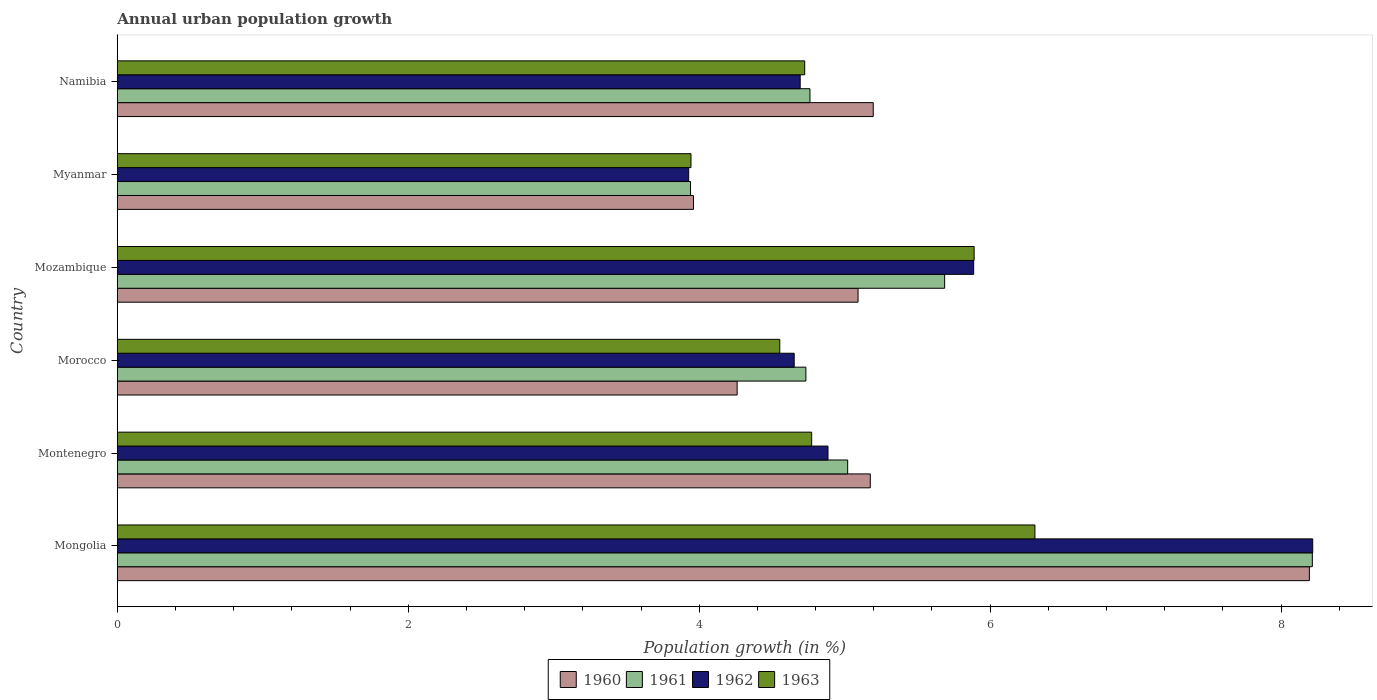How many different coloured bars are there?
Your response must be concise. 4. How many groups of bars are there?
Keep it short and to the point. 6. Are the number of bars on each tick of the Y-axis equal?
Your response must be concise. Yes. How many bars are there on the 4th tick from the bottom?
Your response must be concise. 4. What is the label of the 2nd group of bars from the top?
Provide a succinct answer. Myanmar. What is the percentage of urban population growth in 1963 in Mongolia?
Your answer should be compact. 6.31. Across all countries, what is the maximum percentage of urban population growth in 1960?
Ensure brevity in your answer.  8.19. Across all countries, what is the minimum percentage of urban population growth in 1962?
Make the answer very short. 3.93. In which country was the percentage of urban population growth in 1961 maximum?
Ensure brevity in your answer.  Mongolia. In which country was the percentage of urban population growth in 1962 minimum?
Make the answer very short. Myanmar. What is the total percentage of urban population growth in 1960 in the graph?
Provide a short and direct response. 31.88. What is the difference between the percentage of urban population growth in 1963 in Morocco and that in Namibia?
Give a very brief answer. -0.17. What is the difference between the percentage of urban population growth in 1962 in Morocco and the percentage of urban population growth in 1961 in Myanmar?
Your answer should be very brief. 0.71. What is the average percentage of urban population growth in 1962 per country?
Provide a succinct answer. 5.38. What is the difference between the percentage of urban population growth in 1961 and percentage of urban population growth in 1962 in Morocco?
Your response must be concise. 0.08. What is the ratio of the percentage of urban population growth in 1961 in Morocco to that in Namibia?
Your answer should be very brief. 0.99. Is the percentage of urban population growth in 1963 in Mongolia less than that in Myanmar?
Provide a short and direct response. No. Is the difference between the percentage of urban population growth in 1961 in Montenegro and Namibia greater than the difference between the percentage of urban population growth in 1962 in Montenegro and Namibia?
Ensure brevity in your answer.  Yes. What is the difference between the highest and the second highest percentage of urban population growth in 1960?
Your answer should be compact. 3. What is the difference between the highest and the lowest percentage of urban population growth in 1963?
Provide a succinct answer. 2.36. In how many countries, is the percentage of urban population growth in 1963 greater than the average percentage of urban population growth in 1963 taken over all countries?
Keep it short and to the point. 2. What does the 4th bar from the top in Mongolia represents?
Offer a terse response. 1960. What does the 2nd bar from the bottom in Mozambique represents?
Your response must be concise. 1961. How many bars are there?
Offer a terse response. 24. Are all the bars in the graph horizontal?
Offer a very short reply. Yes. What is the difference between two consecutive major ticks on the X-axis?
Provide a succinct answer. 2. Does the graph contain grids?
Make the answer very short. No. Where does the legend appear in the graph?
Keep it short and to the point. Bottom center. How many legend labels are there?
Provide a succinct answer. 4. How are the legend labels stacked?
Ensure brevity in your answer.  Horizontal. What is the title of the graph?
Your answer should be very brief. Annual urban population growth. Does "1992" appear as one of the legend labels in the graph?
Your answer should be very brief. No. What is the label or title of the X-axis?
Keep it short and to the point. Population growth (in %). What is the label or title of the Y-axis?
Provide a short and direct response. Country. What is the Population growth (in %) in 1960 in Mongolia?
Keep it short and to the point. 8.19. What is the Population growth (in %) in 1961 in Mongolia?
Ensure brevity in your answer.  8.21. What is the Population growth (in %) in 1962 in Mongolia?
Offer a terse response. 8.22. What is the Population growth (in %) in 1963 in Mongolia?
Offer a terse response. 6.31. What is the Population growth (in %) in 1960 in Montenegro?
Offer a very short reply. 5.18. What is the Population growth (in %) in 1961 in Montenegro?
Give a very brief answer. 5.02. What is the Population growth (in %) of 1962 in Montenegro?
Your response must be concise. 4.89. What is the Population growth (in %) in 1963 in Montenegro?
Ensure brevity in your answer.  4.77. What is the Population growth (in %) of 1960 in Morocco?
Your answer should be compact. 4.26. What is the Population growth (in %) in 1961 in Morocco?
Offer a terse response. 4.73. What is the Population growth (in %) in 1962 in Morocco?
Your response must be concise. 4.65. What is the Population growth (in %) in 1963 in Morocco?
Keep it short and to the point. 4.55. What is the Population growth (in %) in 1960 in Mozambique?
Your response must be concise. 5.09. What is the Population growth (in %) in 1961 in Mozambique?
Your response must be concise. 5.69. What is the Population growth (in %) in 1962 in Mozambique?
Your answer should be very brief. 5.89. What is the Population growth (in %) in 1963 in Mozambique?
Offer a very short reply. 5.89. What is the Population growth (in %) in 1960 in Myanmar?
Offer a very short reply. 3.96. What is the Population growth (in %) of 1961 in Myanmar?
Keep it short and to the point. 3.94. What is the Population growth (in %) of 1962 in Myanmar?
Offer a terse response. 3.93. What is the Population growth (in %) of 1963 in Myanmar?
Make the answer very short. 3.94. What is the Population growth (in %) of 1960 in Namibia?
Ensure brevity in your answer.  5.2. What is the Population growth (in %) of 1961 in Namibia?
Keep it short and to the point. 4.76. What is the Population growth (in %) in 1962 in Namibia?
Provide a short and direct response. 4.69. What is the Population growth (in %) in 1963 in Namibia?
Ensure brevity in your answer.  4.73. Across all countries, what is the maximum Population growth (in %) in 1960?
Your answer should be very brief. 8.19. Across all countries, what is the maximum Population growth (in %) in 1961?
Make the answer very short. 8.21. Across all countries, what is the maximum Population growth (in %) of 1962?
Provide a short and direct response. 8.22. Across all countries, what is the maximum Population growth (in %) of 1963?
Offer a very short reply. 6.31. Across all countries, what is the minimum Population growth (in %) of 1960?
Your response must be concise. 3.96. Across all countries, what is the minimum Population growth (in %) of 1961?
Your response must be concise. 3.94. Across all countries, what is the minimum Population growth (in %) in 1962?
Offer a terse response. 3.93. Across all countries, what is the minimum Population growth (in %) in 1963?
Your answer should be very brief. 3.94. What is the total Population growth (in %) in 1960 in the graph?
Your answer should be compact. 31.88. What is the total Population growth (in %) of 1961 in the graph?
Provide a short and direct response. 32.36. What is the total Population growth (in %) in 1962 in the graph?
Provide a short and direct response. 32.26. What is the total Population growth (in %) in 1963 in the graph?
Give a very brief answer. 30.19. What is the difference between the Population growth (in %) in 1960 in Mongolia and that in Montenegro?
Your answer should be compact. 3.02. What is the difference between the Population growth (in %) of 1961 in Mongolia and that in Montenegro?
Ensure brevity in your answer.  3.19. What is the difference between the Population growth (in %) of 1962 in Mongolia and that in Montenegro?
Keep it short and to the point. 3.33. What is the difference between the Population growth (in %) in 1963 in Mongolia and that in Montenegro?
Ensure brevity in your answer.  1.53. What is the difference between the Population growth (in %) in 1960 in Mongolia and that in Morocco?
Provide a succinct answer. 3.93. What is the difference between the Population growth (in %) in 1961 in Mongolia and that in Morocco?
Your response must be concise. 3.48. What is the difference between the Population growth (in %) in 1962 in Mongolia and that in Morocco?
Your answer should be very brief. 3.56. What is the difference between the Population growth (in %) of 1963 in Mongolia and that in Morocco?
Make the answer very short. 1.75. What is the difference between the Population growth (in %) in 1960 in Mongolia and that in Mozambique?
Your answer should be very brief. 3.1. What is the difference between the Population growth (in %) of 1961 in Mongolia and that in Mozambique?
Offer a terse response. 2.53. What is the difference between the Population growth (in %) of 1962 in Mongolia and that in Mozambique?
Ensure brevity in your answer.  2.33. What is the difference between the Population growth (in %) in 1963 in Mongolia and that in Mozambique?
Keep it short and to the point. 0.42. What is the difference between the Population growth (in %) of 1960 in Mongolia and that in Myanmar?
Your answer should be very brief. 4.23. What is the difference between the Population growth (in %) of 1961 in Mongolia and that in Myanmar?
Your answer should be very brief. 4.27. What is the difference between the Population growth (in %) in 1962 in Mongolia and that in Myanmar?
Give a very brief answer. 4.29. What is the difference between the Population growth (in %) in 1963 in Mongolia and that in Myanmar?
Provide a short and direct response. 2.36. What is the difference between the Population growth (in %) of 1960 in Mongolia and that in Namibia?
Give a very brief answer. 3. What is the difference between the Population growth (in %) in 1961 in Mongolia and that in Namibia?
Your answer should be compact. 3.45. What is the difference between the Population growth (in %) of 1962 in Mongolia and that in Namibia?
Make the answer very short. 3.52. What is the difference between the Population growth (in %) of 1963 in Mongolia and that in Namibia?
Offer a terse response. 1.58. What is the difference between the Population growth (in %) in 1960 in Montenegro and that in Morocco?
Your answer should be compact. 0.92. What is the difference between the Population growth (in %) of 1961 in Montenegro and that in Morocco?
Provide a succinct answer. 0.29. What is the difference between the Population growth (in %) of 1962 in Montenegro and that in Morocco?
Your answer should be very brief. 0.23. What is the difference between the Population growth (in %) in 1963 in Montenegro and that in Morocco?
Ensure brevity in your answer.  0.22. What is the difference between the Population growth (in %) in 1960 in Montenegro and that in Mozambique?
Provide a succinct answer. 0.08. What is the difference between the Population growth (in %) in 1962 in Montenegro and that in Mozambique?
Give a very brief answer. -1. What is the difference between the Population growth (in %) in 1963 in Montenegro and that in Mozambique?
Make the answer very short. -1.12. What is the difference between the Population growth (in %) in 1960 in Montenegro and that in Myanmar?
Your response must be concise. 1.22. What is the difference between the Population growth (in %) of 1962 in Montenegro and that in Myanmar?
Offer a very short reply. 0.96. What is the difference between the Population growth (in %) in 1963 in Montenegro and that in Myanmar?
Make the answer very short. 0.83. What is the difference between the Population growth (in %) of 1960 in Montenegro and that in Namibia?
Your response must be concise. -0.02. What is the difference between the Population growth (in %) in 1961 in Montenegro and that in Namibia?
Your answer should be compact. 0.26. What is the difference between the Population growth (in %) of 1962 in Montenegro and that in Namibia?
Make the answer very short. 0.19. What is the difference between the Population growth (in %) of 1963 in Montenegro and that in Namibia?
Offer a terse response. 0.05. What is the difference between the Population growth (in %) of 1960 in Morocco and that in Mozambique?
Keep it short and to the point. -0.83. What is the difference between the Population growth (in %) in 1961 in Morocco and that in Mozambique?
Your answer should be very brief. -0.95. What is the difference between the Population growth (in %) of 1962 in Morocco and that in Mozambique?
Give a very brief answer. -1.23. What is the difference between the Population growth (in %) of 1963 in Morocco and that in Mozambique?
Ensure brevity in your answer.  -1.34. What is the difference between the Population growth (in %) in 1960 in Morocco and that in Myanmar?
Offer a very short reply. 0.3. What is the difference between the Population growth (in %) of 1961 in Morocco and that in Myanmar?
Provide a short and direct response. 0.79. What is the difference between the Population growth (in %) of 1962 in Morocco and that in Myanmar?
Offer a very short reply. 0.73. What is the difference between the Population growth (in %) of 1963 in Morocco and that in Myanmar?
Your answer should be very brief. 0.61. What is the difference between the Population growth (in %) of 1960 in Morocco and that in Namibia?
Make the answer very short. -0.94. What is the difference between the Population growth (in %) in 1961 in Morocco and that in Namibia?
Provide a short and direct response. -0.03. What is the difference between the Population growth (in %) of 1962 in Morocco and that in Namibia?
Provide a short and direct response. -0.04. What is the difference between the Population growth (in %) in 1963 in Morocco and that in Namibia?
Ensure brevity in your answer.  -0.17. What is the difference between the Population growth (in %) in 1960 in Mozambique and that in Myanmar?
Provide a short and direct response. 1.13. What is the difference between the Population growth (in %) of 1961 in Mozambique and that in Myanmar?
Give a very brief answer. 1.75. What is the difference between the Population growth (in %) in 1962 in Mozambique and that in Myanmar?
Offer a terse response. 1.96. What is the difference between the Population growth (in %) in 1963 in Mozambique and that in Myanmar?
Offer a very short reply. 1.95. What is the difference between the Population growth (in %) in 1960 in Mozambique and that in Namibia?
Your answer should be very brief. -0.1. What is the difference between the Population growth (in %) of 1961 in Mozambique and that in Namibia?
Make the answer very short. 0.93. What is the difference between the Population growth (in %) of 1962 in Mozambique and that in Namibia?
Give a very brief answer. 1.19. What is the difference between the Population growth (in %) of 1963 in Mozambique and that in Namibia?
Give a very brief answer. 1.16. What is the difference between the Population growth (in %) in 1960 in Myanmar and that in Namibia?
Make the answer very short. -1.24. What is the difference between the Population growth (in %) in 1961 in Myanmar and that in Namibia?
Provide a short and direct response. -0.82. What is the difference between the Population growth (in %) in 1962 in Myanmar and that in Namibia?
Your response must be concise. -0.77. What is the difference between the Population growth (in %) of 1963 in Myanmar and that in Namibia?
Ensure brevity in your answer.  -0.78. What is the difference between the Population growth (in %) of 1960 in Mongolia and the Population growth (in %) of 1961 in Montenegro?
Keep it short and to the point. 3.17. What is the difference between the Population growth (in %) of 1960 in Mongolia and the Population growth (in %) of 1962 in Montenegro?
Give a very brief answer. 3.31. What is the difference between the Population growth (in %) of 1960 in Mongolia and the Population growth (in %) of 1963 in Montenegro?
Your answer should be very brief. 3.42. What is the difference between the Population growth (in %) in 1961 in Mongolia and the Population growth (in %) in 1962 in Montenegro?
Your response must be concise. 3.33. What is the difference between the Population growth (in %) of 1961 in Mongolia and the Population growth (in %) of 1963 in Montenegro?
Provide a short and direct response. 3.44. What is the difference between the Population growth (in %) in 1962 in Mongolia and the Population growth (in %) in 1963 in Montenegro?
Provide a short and direct response. 3.44. What is the difference between the Population growth (in %) in 1960 in Mongolia and the Population growth (in %) in 1961 in Morocco?
Ensure brevity in your answer.  3.46. What is the difference between the Population growth (in %) of 1960 in Mongolia and the Population growth (in %) of 1962 in Morocco?
Offer a very short reply. 3.54. What is the difference between the Population growth (in %) in 1960 in Mongolia and the Population growth (in %) in 1963 in Morocco?
Make the answer very short. 3.64. What is the difference between the Population growth (in %) in 1961 in Mongolia and the Population growth (in %) in 1962 in Morocco?
Provide a succinct answer. 3.56. What is the difference between the Population growth (in %) in 1961 in Mongolia and the Population growth (in %) in 1963 in Morocco?
Keep it short and to the point. 3.66. What is the difference between the Population growth (in %) in 1962 in Mongolia and the Population growth (in %) in 1963 in Morocco?
Make the answer very short. 3.66. What is the difference between the Population growth (in %) of 1960 in Mongolia and the Population growth (in %) of 1961 in Mozambique?
Ensure brevity in your answer.  2.51. What is the difference between the Population growth (in %) in 1960 in Mongolia and the Population growth (in %) in 1962 in Mozambique?
Give a very brief answer. 2.31. What is the difference between the Population growth (in %) in 1960 in Mongolia and the Population growth (in %) in 1963 in Mozambique?
Offer a terse response. 2.3. What is the difference between the Population growth (in %) in 1961 in Mongolia and the Population growth (in %) in 1962 in Mozambique?
Your answer should be very brief. 2.33. What is the difference between the Population growth (in %) in 1961 in Mongolia and the Population growth (in %) in 1963 in Mozambique?
Offer a terse response. 2.32. What is the difference between the Population growth (in %) of 1962 in Mongolia and the Population growth (in %) of 1963 in Mozambique?
Provide a succinct answer. 2.33. What is the difference between the Population growth (in %) in 1960 in Mongolia and the Population growth (in %) in 1961 in Myanmar?
Provide a short and direct response. 4.25. What is the difference between the Population growth (in %) in 1960 in Mongolia and the Population growth (in %) in 1962 in Myanmar?
Your response must be concise. 4.27. What is the difference between the Population growth (in %) of 1960 in Mongolia and the Population growth (in %) of 1963 in Myanmar?
Your response must be concise. 4.25. What is the difference between the Population growth (in %) of 1961 in Mongolia and the Population growth (in %) of 1962 in Myanmar?
Give a very brief answer. 4.29. What is the difference between the Population growth (in %) of 1961 in Mongolia and the Population growth (in %) of 1963 in Myanmar?
Your answer should be compact. 4.27. What is the difference between the Population growth (in %) in 1962 in Mongolia and the Population growth (in %) in 1963 in Myanmar?
Provide a succinct answer. 4.27. What is the difference between the Population growth (in %) in 1960 in Mongolia and the Population growth (in %) in 1961 in Namibia?
Make the answer very short. 3.43. What is the difference between the Population growth (in %) of 1960 in Mongolia and the Population growth (in %) of 1963 in Namibia?
Provide a short and direct response. 3.47. What is the difference between the Population growth (in %) of 1961 in Mongolia and the Population growth (in %) of 1962 in Namibia?
Keep it short and to the point. 3.52. What is the difference between the Population growth (in %) of 1961 in Mongolia and the Population growth (in %) of 1963 in Namibia?
Provide a succinct answer. 3.49. What is the difference between the Population growth (in %) in 1962 in Mongolia and the Population growth (in %) in 1963 in Namibia?
Your answer should be compact. 3.49. What is the difference between the Population growth (in %) of 1960 in Montenegro and the Population growth (in %) of 1961 in Morocco?
Provide a short and direct response. 0.44. What is the difference between the Population growth (in %) in 1960 in Montenegro and the Population growth (in %) in 1962 in Morocco?
Provide a succinct answer. 0.52. What is the difference between the Population growth (in %) of 1960 in Montenegro and the Population growth (in %) of 1963 in Morocco?
Provide a short and direct response. 0.62. What is the difference between the Population growth (in %) of 1961 in Montenegro and the Population growth (in %) of 1962 in Morocco?
Keep it short and to the point. 0.37. What is the difference between the Population growth (in %) of 1961 in Montenegro and the Population growth (in %) of 1963 in Morocco?
Provide a short and direct response. 0.47. What is the difference between the Population growth (in %) of 1962 in Montenegro and the Population growth (in %) of 1963 in Morocco?
Your answer should be compact. 0.33. What is the difference between the Population growth (in %) in 1960 in Montenegro and the Population growth (in %) in 1961 in Mozambique?
Offer a very short reply. -0.51. What is the difference between the Population growth (in %) of 1960 in Montenegro and the Population growth (in %) of 1962 in Mozambique?
Make the answer very short. -0.71. What is the difference between the Population growth (in %) of 1960 in Montenegro and the Population growth (in %) of 1963 in Mozambique?
Keep it short and to the point. -0.71. What is the difference between the Population growth (in %) in 1961 in Montenegro and the Population growth (in %) in 1962 in Mozambique?
Give a very brief answer. -0.87. What is the difference between the Population growth (in %) in 1961 in Montenegro and the Population growth (in %) in 1963 in Mozambique?
Ensure brevity in your answer.  -0.87. What is the difference between the Population growth (in %) of 1962 in Montenegro and the Population growth (in %) of 1963 in Mozambique?
Your answer should be very brief. -1. What is the difference between the Population growth (in %) in 1960 in Montenegro and the Population growth (in %) in 1961 in Myanmar?
Your answer should be very brief. 1.24. What is the difference between the Population growth (in %) in 1960 in Montenegro and the Population growth (in %) in 1962 in Myanmar?
Provide a short and direct response. 1.25. What is the difference between the Population growth (in %) of 1960 in Montenegro and the Population growth (in %) of 1963 in Myanmar?
Your response must be concise. 1.23. What is the difference between the Population growth (in %) of 1961 in Montenegro and the Population growth (in %) of 1962 in Myanmar?
Ensure brevity in your answer.  1.09. What is the difference between the Population growth (in %) in 1961 in Montenegro and the Population growth (in %) in 1963 in Myanmar?
Provide a short and direct response. 1.08. What is the difference between the Population growth (in %) of 1962 in Montenegro and the Population growth (in %) of 1963 in Myanmar?
Give a very brief answer. 0.94. What is the difference between the Population growth (in %) in 1960 in Montenegro and the Population growth (in %) in 1961 in Namibia?
Give a very brief answer. 0.41. What is the difference between the Population growth (in %) in 1960 in Montenegro and the Population growth (in %) in 1962 in Namibia?
Offer a terse response. 0.48. What is the difference between the Population growth (in %) of 1960 in Montenegro and the Population growth (in %) of 1963 in Namibia?
Your response must be concise. 0.45. What is the difference between the Population growth (in %) of 1961 in Montenegro and the Population growth (in %) of 1962 in Namibia?
Provide a succinct answer. 0.33. What is the difference between the Population growth (in %) in 1961 in Montenegro and the Population growth (in %) in 1963 in Namibia?
Your answer should be very brief. 0.3. What is the difference between the Population growth (in %) in 1962 in Montenegro and the Population growth (in %) in 1963 in Namibia?
Offer a terse response. 0.16. What is the difference between the Population growth (in %) in 1960 in Morocco and the Population growth (in %) in 1961 in Mozambique?
Your answer should be compact. -1.43. What is the difference between the Population growth (in %) of 1960 in Morocco and the Population growth (in %) of 1962 in Mozambique?
Your response must be concise. -1.63. What is the difference between the Population growth (in %) of 1960 in Morocco and the Population growth (in %) of 1963 in Mozambique?
Offer a very short reply. -1.63. What is the difference between the Population growth (in %) of 1961 in Morocco and the Population growth (in %) of 1962 in Mozambique?
Keep it short and to the point. -1.15. What is the difference between the Population growth (in %) in 1961 in Morocco and the Population growth (in %) in 1963 in Mozambique?
Ensure brevity in your answer.  -1.16. What is the difference between the Population growth (in %) of 1962 in Morocco and the Population growth (in %) of 1963 in Mozambique?
Ensure brevity in your answer.  -1.24. What is the difference between the Population growth (in %) of 1960 in Morocco and the Population growth (in %) of 1961 in Myanmar?
Make the answer very short. 0.32. What is the difference between the Population growth (in %) of 1960 in Morocco and the Population growth (in %) of 1962 in Myanmar?
Make the answer very short. 0.33. What is the difference between the Population growth (in %) in 1960 in Morocco and the Population growth (in %) in 1963 in Myanmar?
Provide a short and direct response. 0.32. What is the difference between the Population growth (in %) of 1961 in Morocco and the Population growth (in %) of 1962 in Myanmar?
Offer a terse response. 0.81. What is the difference between the Population growth (in %) of 1961 in Morocco and the Population growth (in %) of 1963 in Myanmar?
Keep it short and to the point. 0.79. What is the difference between the Population growth (in %) in 1962 in Morocco and the Population growth (in %) in 1963 in Myanmar?
Your response must be concise. 0.71. What is the difference between the Population growth (in %) in 1960 in Morocco and the Population growth (in %) in 1961 in Namibia?
Your response must be concise. -0.5. What is the difference between the Population growth (in %) of 1960 in Morocco and the Population growth (in %) of 1962 in Namibia?
Provide a short and direct response. -0.43. What is the difference between the Population growth (in %) of 1960 in Morocco and the Population growth (in %) of 1963 in Namibia?
Make the answer very short. -0.46. What is the difference between the Population growth (in %) in 1961 in Morocco and the Population growth (in %) in 1962 in Namibia?
Provide a succinct answer. 0.04. What is the difference between the Population growth (in %) of 1961 in Morocco and the Population growth (in %) of 1963 in Namibia?
Offer a terse response. 0.01. What is the difference between the Population growth (in %) in 1962 in Morocco and the Population growth (in %) in 1963 in Namibia?
Provide a short and direct response. -0.07. What is the difference between the Population growth (in %) in 1960 in Mozambique and the Population growth (in %) in 1961 in Myanmar?
Make the answer very short. 1.15. What is the difference between the Population growth (in %) in 1960 in Mozambique and the Population growth (in %) in 1962 in Myanmar?
Offer a terse response. 1.16. What is the difference between the Population growth (in %) of 1960 in Mozambique and the Population growth (in %) of 1963 in Myanmar?
Your response must be concise. 1.15. What is the difference between the Population growth (in %) of 1961 in Mozambique and the Population growth (in %) of 1962 in Myanmar?
Make the answer very short. 1.76. What is the difference between the Population growth (in %) in 1961 in Mozambique and the Population growth (in %) in 1963 in Myanmar?
Provide a succinct answer. 1.74. What is the difference between the Population growth (in %) of 1962 in Mozambique and the Population growth (in %) of 1963 in Myanmar?
Provide a succinct answer. 1.94. What is the difference between the Population growth (in %) of 1960 in Mozambique and the Population growth (in %) of 1961 in Namibia?
Keep it short and to the point. 0.33. What is the difference between the Population growth (in %) in 1960 in Mozambique and the Population growth (in %) in 1962 in Namibia?
Offer a terse response. 0.4. What is the difference between the Population growth (in %) of 1960 in Mozambique and the Population growth (in %) of 1963 in Namibia?
Give a very brief answer. 0.37. What is the difference between the Population growth (in %) in 1961 in Mozambique and the Population growth (in %) in 1963 in Namibia?
Provide a short and direct response. 0.96. What is the difference between the Population growth (in %) in 1962 in Mozambique and the Population growth (in %) in 1963 in Namibia?
Your answer should be very brief. 1.16. What is the difference between the Population growth (in %) in 1960 in Myanmar and the Population growth (in %) in 1961 in Namibia?
Offer a very short reply. -0.8. What is the difference between the Population growth (in %) in 1960 in Myanmar and the Population growth (in %) in 1962 in Namibia?
Provide a short and direct response. -0.73. What is the difference between the Population growth (in %) of 1960 in Myanmar and the Population growth (in %) of 1963 in Namibia?
Keep it short and to the point. -0.76. What is the difference between the Population growth (in %) in 1961 in Myanmar and the Population growth (in %) in 1962 in Namibia?
Offer a terse response. -0.75. What is the difference between the Population growth (in %) in 1961 in Myanmar and the Population growth (in %) in 1963 in Namibia?
Make the answer very short. -0.78. What is the difference between the Population growth (in %) of 1962 in Myanmar and the Population growth (in %) of 1963 in Namibia?
Your response must be concise. -0.8. What is the average Population growth (in %) of 1960 per country?
Your answer should be compact. 5.31. What is the average Population growth (in %) of 1961 per country?
Your response must be concise. 5.39. What is the average Population growth (in %) in 1962 per country?
Provide a short and direct response. 5.38. What is the average Population growth (in %) in 1963 per country?
Ensure brevity in your answer.  5.03. What is the difference between the Population growth (in %) in 1960 and Population growth (in %) in 1961 in Mongolia?
Offer a very short reply. -0.02. What is the difference between the Population growth (in %) of 1960 and Population growth (in %) of 1962 in Mongolia?
Your answer should be very brief. -0.02. What is the difference between the Population growth (in %) of 1960 and Population growth (in %) of 1963 in Mongolia?
Ensure brevity in your answer.  1.89. What is the difference between the Population growth (in %) of 1961 and Population growth (in %) of 1962 in Mongolia?
Your answer should be very brief. -0. What is the difference between the Population growth (in %) of 1961 and Population growth (in %) of 1963 in Mongolia?
Ensure brevity in your answer.  1.91. What is the difference between the Population growth (in %) of 1962 and Population growth (in %) of 1963 in Mongolia?
Provide a short and direct response. 1.91. What is the difference between the Population growth (in %) in 1960 and Population growth (in %) in 1961 in Montenegro?
Make the answer very short. 0.16. What is the difference between the Population growth (in %) of 1960 and Population growth (in %) of 1962 in Montenegro?
Ensure brevity in your answer.  0.29. What is the difference between the Population growth (in %) in 1960 and Population growth (in %) in 1963 in Montenegro?
Keep it short and to the point. 0.4. What is the difference between the Population growth (in %) in 1961 and Population growth (in %) in 1962 in Montenegro?
Keep it short and to the point. 0.14. What is the difference between the Population growth (in %) in 1961 and Population growth (in %) in 1963 in Montenegro?
Offer a very short reply. 0.25. What is the difference between the Population growth (in %) in 1962 and Population growth (in %) in 1963 in Montenegro?
Provide a short and direct response. 0.11. What is the difference between the Population growth (in %) of 1960 and Population growth (in %) of 1961 in Morocco?
Provide a short and direct response. -0.47. What is the difference between the Population growth (in %) of 1960 and Population growth (in %) of 1962 in Morocco?
Give a very brief answer. -0.39. What is the difference between the Population growth (in %) in 1960 and Population growth (in %) in 1963 in Morocco?
Offer a terse response. -0.29. What is the difference between the Population growth (in %) of 1961 and Population growth (in %) of 1962 in Morocco?
Offer a very short reply. 0.08. What is the difference between the Population growth (in %) in 1961 and Population growth (in %) in 1963 in Morocco?
Provide a succinct answer. 0.18. What is the difference between the Population growth (in %) in 1962 and Population growth (in %) in 1963 in Morocco?
Your response must be concise. 0.1. What is the difference between the Population growth (in %) in 1960 and Population growth (in %) in 1961 in Mozambique?
Your answer should be compact. -0.6. What is the difference between the Population growth (in %) in 1960 and Population growth (in %) in 1962 in Mozambique?
Your answer should be very brief. -0.79. What is the difference between the Population growth (in %) of 1960 and Population growth (in %) of 1963 in Mozambique?
Provide a succinct answer. -0.8. What is the difference between the Population growth (in %) in 1961 and Population growth (in %) in 1962 in Mozambique?
Offer a terse response. -0.2. What is the difference between the Population growth (in %) of 1961 and Population growth (in %) of 1963 in Mozambique?
Your response must be concise. -0.2. What is the difference between the Population growth (in %) in 1962 and Population growth (in %) in 1963 in Mozambique?
Offer a very short reply. -0. What is the difference between the Population growth (in %) of 1960 and Population growth (in %) of 1961 in Myanmar?
Offer a terse response. 0.02. What is the difference between the Population growth (in %) of 1960 and Population growth (in %) of 1962 in Myanmar?
Provide a short and direct response. 0.03. What is the difference between the Population growth (in %) in 1960 and Population growth (in %) in 1963 in Myanmar?
Your response must be concise. 0.02. What is the difference between the Population growth (in %) of 1961 and Population growth (in %) of 1962 in Myanmar?
Provide a short and direct response. 0.01. What is the difference between the Population growth (in %) of 1961 and Population growth (in %) of 1963 in Myanmar?
Your answer should be compact. -0. What is the difference between the Population growth (in %) of 1962 and Population growth (in %) of 1963 in Myanmar?
Keep it short and to the point. -0.02. What is the difference between the Population growth (in %) in 1960 and Population growth (in %) in 1961 in Namibia?
Make the answer very short. 0.43. What is the difference between the Population growth (in %) of 1960 and Population growth (in %) of 1962 in Namibia?
Offer a terse response. 0.5. What is the difference between the Population growth (in %) in 1960 and Population growth (in %) in 1963 in Namibia?
Your response must be concise. 0.47. What is the difference between the Population growth (in %) of 1961 and Population growth (in %) of 1962 in Namibia?
Give a very brief answer. 0.07. What is the difference between the Population growth (in %) of 1961 and Population growth (in %) of 1963 in Namibia?
Keep it short and to the point. 0.04. What is the difference between the Population growth (in %) of 1962 and Population growth (in %) of 1963 in Namibia?
Offer a terse response. -0.03. What is the ratio of the Population growth (in %) in 1960 in Mongolia to that in Montenegro?
Your answer should be very brief. 1.58. What is the ratio of the Population growth (in %) of 1961 in Mongolia to that in Montenegro?
Provide a short and direct response. 1.64. What is the ratio of the Population growth (in %) of 1962 in Mongolia to that in Montenegro?
Your answer should be very brief. 1.68. What is the ratio of the Population growth (in %) in 1963 in Mongolia to that in Montenegro?
Your answer should be compact. 1.32. What is the ratio of the Population growth (in %) in 1960 in Mongolia to that in Morocco?
Provide a short and direct response. 1.92. What is the ratio of the Population growth (in %) of 1961 in Mongolia to that in Morocco?
Ensure brevity in your answer.  1.74. What is the ratio of the Population growth (in %) in 1962 in Mongolia to that in Morocco?
Give a very brief answer. 1.77. What is the ratio of the Population growth (in %) in 1963 in Mongolia to that in Morocco?
Provide a succinct answer. 1.39. What is the ratio of the Population growth (in %) in 1960 in Mongolia to that in Mozambique?
Give a very brief answer. 1.61. What is the ratio of the Population growth (in %) of 1961 in Mongolia to that in Mozambique?
Keep it short and to the point. 1.44. What is the ratio of the Population growth (in %) of 1962 in Mongolia to that in Mozambique?
Offer a very short reply. 1.4. What is the ratio of the Population growth (in %) in 1963 in Mongolia to that in Mozambique?
Your answer should be very brief. 1.07. What is the ratio of the Population growth (in %) in 1960 in Mongolia to that in Myanmar?
Ensure brevity in your answer.  2.07. What is the ratio of the Population growth (in %) of 1961 in Mongolia to that in Myanmar?
Offer a terse response. 2.08. What is the ratio of the Population growth (in %) of 1962 in Mongolia to that in Myanmar?
Keep it short and to the point. 2.09. What is the ratio of the Population growth (in %) in 1963 in Mongolia to that in Myanmar?
Your response must be concise. 1.6. What is the ratio of the Population growth (in %) in 1960 in Mongolia to that in Namibia?
Make the answer very short. 1.58. What is the ratio of the Population growth (in %) in 1961 in Mongolia to that in Namibia?
Make the answer very short. 1.73. What is the ratio of the Population growth (in %) of 1962 in Mongolia to that in Namibia?
Offer a terse response. 1.75. What is the ratio of the Population growth (in %) in 1963 in Mongolia to that in Namibia?
Give a very brief answer. 1.33. What is the ratio of the Population growth (in %) in 1960 in Montenegro to that in Morocco?
Offer a terse response. 1.21. What is the ratio of the Population growth (in %) in 1961 in Montenegro to that in Morocco?
Your answer should be very brief. 1.06. What is the ratio of the Population growth (in %) in 1962 in Montenegro to that in Morocco?
Offer a very short reply. 1.05. What is the ratio of the Population growth (in %) of 1963 in Montenegro to that in Morocco?
Ensure brevity in your answer.  1.05. What is the ratio of the Population growth (in %) in 1960 in Montenegro to that in Mozambique?
Your answer should be very brief. 1.02. What is the ratio of the Population growth (in %) of 1961 in Montenegro to that in Mozambique?
Your answer should be compact. 0.88. What is the ratio of the Population growth (in %) in 1962 in Montenegro to that in Mozambique?
Keep it short and to the point. 0.83. What is the ratio of the Population growth (in %) of 1963 in Montenegro to that in Mozambique?
Your answer should be very brief. 0.81. What is the ratio of the Population growth (in %) in 1960 in Montenegro to that in Myanmar?
Your response must be concise. 1.31. What is the ratio of the Population growth (in %) in 1961 in Montenegro to that in Myanmar?
Provide a succinct answer. 1.27. What is the ratio of the Population growth (in %) of 1962 in Montenegro to that in Myanmar?
Provide a short and direct response. 1.24. What is the ratio of the Population growth (in %) in 1963 in Montenegro to that in Myanmar?
Provide a short and direct response. 1.21. What is the ratio of the Population growth (in %) of 1960 in Montenegro to that in Namibia?
Your answer should be very brief. 1. What is the ratio of the Population growth (in %) in 1961 in Montenegro to that in Namibia?
Make the answer very short. 1.05. What is the ratio of the Population growth (in %) in 1962 in Montenegro to that in Namibia?
Keep it short and to the point. 1.04. What is the ratio of the Population growth (in %) in 1963 in Montenegro to that in Namibia?
Your answer should be compact. 1.01. What is the ratio of the Population growth (in %) of 1960 in Morocco to that in Mozambique?
Your answer should be very brief. 0.84. What is the ratio of the Population growth (in %) in 1961 in Morocco to that in Mozambique?
Ensure brevity in your answer.  0.83. What is the ratio of the Population growth (in %) in 1962 in Morocco to that in Mozambique?
Keep it short and to the point. 0.79. What is the ratio of the Population growth (in %) in 1963 in Morocco to that in Mozambique?
Offer a terse response. 0.77. What is the ratio of the Population growth (in %) of 1960 in Morocco to that in Myanmar?
Give a very brief answer. 1.08. What is the ratio of the Population growth (in %) of 1961 in Morocco to that in Myanmar?
Keep it short and to the point. 1.2. What is the ratio of the Population growth (in %) of 1962 in Morocco to that in Myanmar?
Ensure brevity in your answer.  1.18. What is the ratio of the Population growth (in %) in 1963 in Morocco to that in Myanmar?
Give a very brief answer. 1.15. What is the ratio of the Population growth (in %) in 1960 in Morocco to that in Namibia?
Offer a very short reply. 0.82. What is the ratio of the Population growth (in %) of 1963 in Morocco to that in Namibia?
Offer a terse response. 0.96. What is the ratio of the Population growth (in %) of 1960 in Mozambique to that in Myanmar?
Make the answer very short. 1.29. What is the ratio of the Population growth (in %) of 1961 in Mozambique to that in Myanmar?
Your answer should be very brief. 1.44. What is the ratio of the Population growth (in %) of 1962 in Mozambique to that in Myanmar?
Ensure brevity in your answer.  1.5. What is the ratio of the Population growth (in %) of 1963 in Mozambique to that in Myanmar?
Your answer should be compact. 1.49. What is the ratio of the Population growth (in %) of 1960 in Mozambique to that in Namibia?
Your response must be concise. 0.98. What is the ratio of the Population growth (in %) in 1961 in Mozambique to that in Namibia?
Your response must be concise. 1.19. What is the ratio of the Population growth (in %) of 1962 in Mozambique to that in Namibia?
Give a very brief answer. 1.25. What is the ratio of the Population growth (in %) of 1963 in Mozambique to that in Namibia?
Offer a terse response. 1.25. What is the ratio of the Population growth (in %) in 1960 in Myanmar to that in Namibia?
Ensure brevity in your answer.  0.76. What is the ratio of the Population growth (in %) in 1961 in Myanmar to that in Namibia?
Your answer should be very brief. 0.83. What is the ratio of the Population growth (in %) in 1962 in Myanmar to that in Namibia?
Provide a succinct answer. 0.84. What is the ratio of the Population growth (in %) in 1963 in Myanmar to that in Namibia?
Keep it short and to the point. 0.83. What is the difference between the highest and the second highest Population growth (in %) of 1960?
Give a very brief answer. 3. What is the difference between the highest and the second highest Population growth (in %) of 1961?
Provide a succinct answer. 2.53. What is the difference between the highest and the second highest Population growth (in %) in 1962?
Your answer should be very brief. 2.33. What is the difference between the highest and the second highest Population growth (in %) in 1963?
Provide a succinct answer. 0.42. What is the difference between the highest and the lowest Population growth (in %) in 1960?
Provide a short and direct response. 4.23. What is the difference between the highest and the lowest Population growth (in %) of 1961?
Your answer should be compact. 4.27. What is the difference between the highest and the lowest Population growth (in %) of 1962?
Your answer should be compact. 4.29. What is the difference between the highest and the lowest Population growth (in %) of 1963?
Offer a terse response. 2.36. 